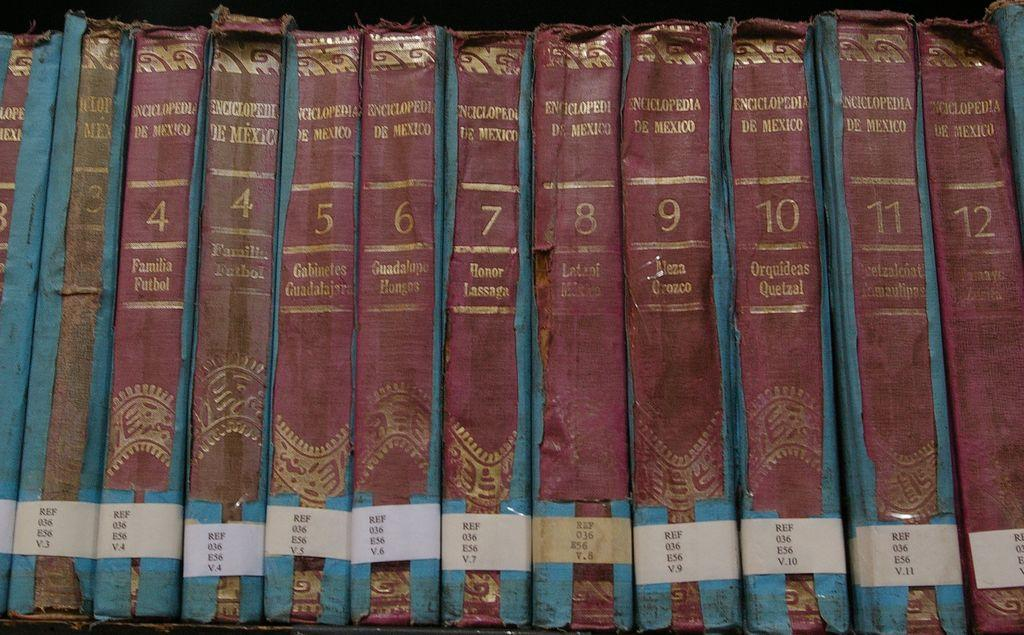<image>
Summarize the visual content of the image. The books here have exactly twelve volumes in the series 